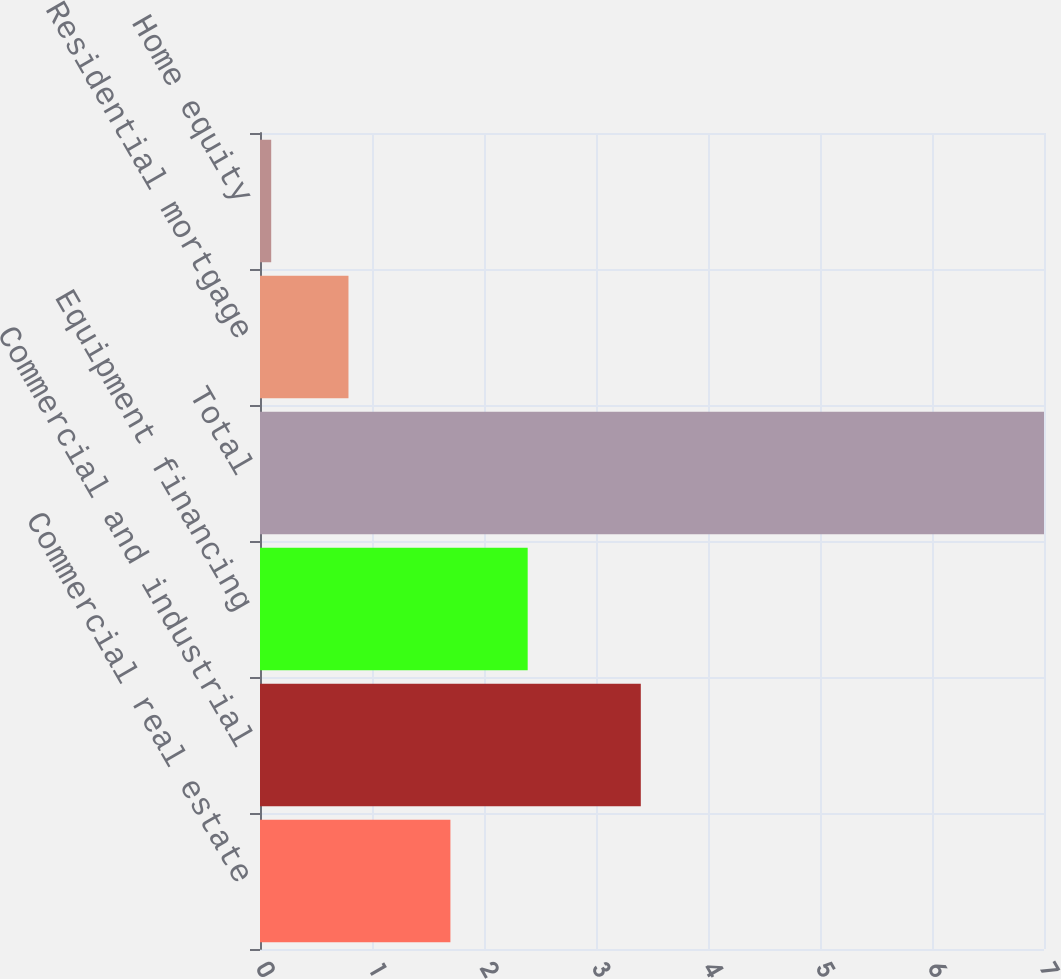Convert chart to OTSL. <chart><loc_0><loc_0><loc_500><loc_500><bar_chart><fcel>Commercial real estate<fcel>Commercial and industrial<fcel>Equipment financing<fcel>Total<fcel>Residential mortgage<fcel>Home equity<nl><fcel>1.7<fcel>3.4<fcel>2.39<fcel>7<fcel>0.79<fcel>0.1<nl></chart> 